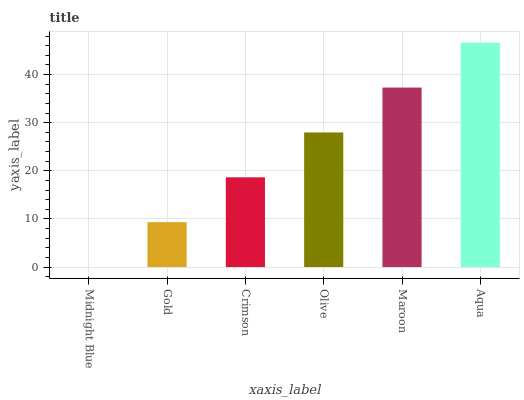Is Midnight Blue the minimum?
Answer yes or no. Yes. Is Aqua the maximum?
Answer yes or no. Yes. Is Gold the minimum?
Answer yes or no. No. Is Gold the maximum?
Answer yes or no. No. Is Gold greater than Midnight Blue?
Answer yes or no. Yes. Is Midnight Blue less than Gold?
Answer yes or no. Yes. Is Midnight Blue greater than Gold?
Answer yes or no. No. Is Gold less than Midnight Blue?
Answer yes or no. No. Is Olive the high median?
Answer yes or no. Yes. Is Crimson the low median?
Answer yes or no. Yes. Is Aqua the high median?
Answer yes or no. No. Is Gold the low median?
Answer yes or no. No. 